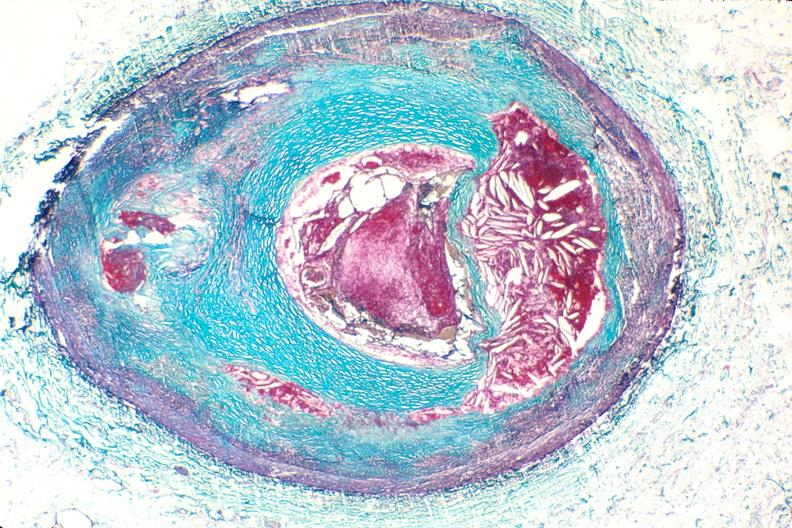does this image show right coronary artery, atherosclerosis and acute thrombus?
Answer the question using a single word or phrase. Yes 